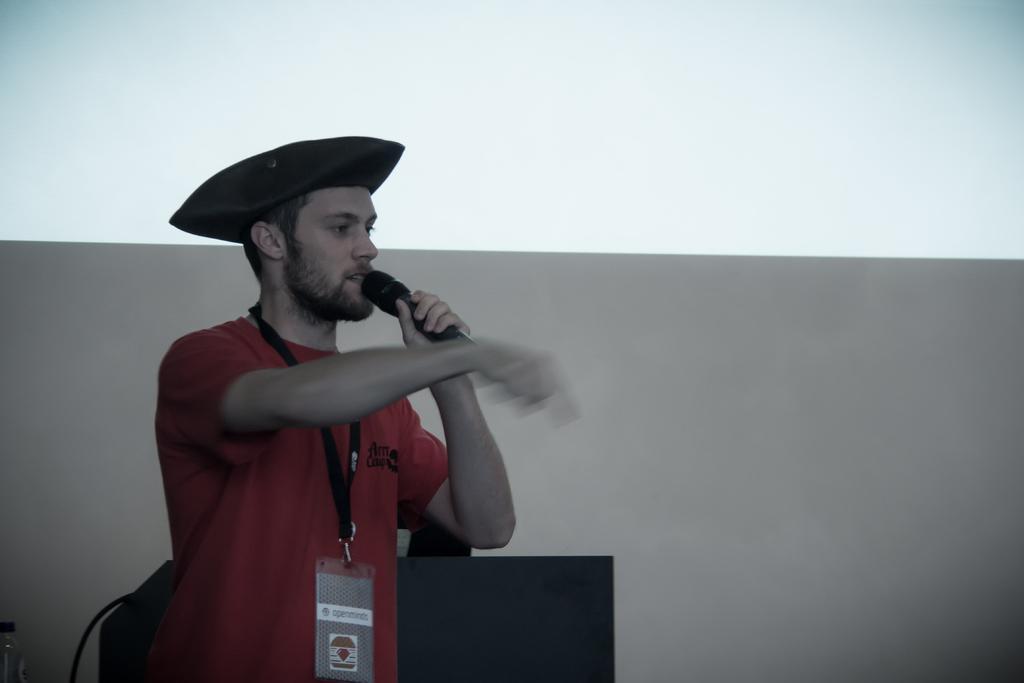In one or two sentences, can you explain what this image depicts? In this picture There is a person standing hold a microphone. He wear cap. This is podium. 